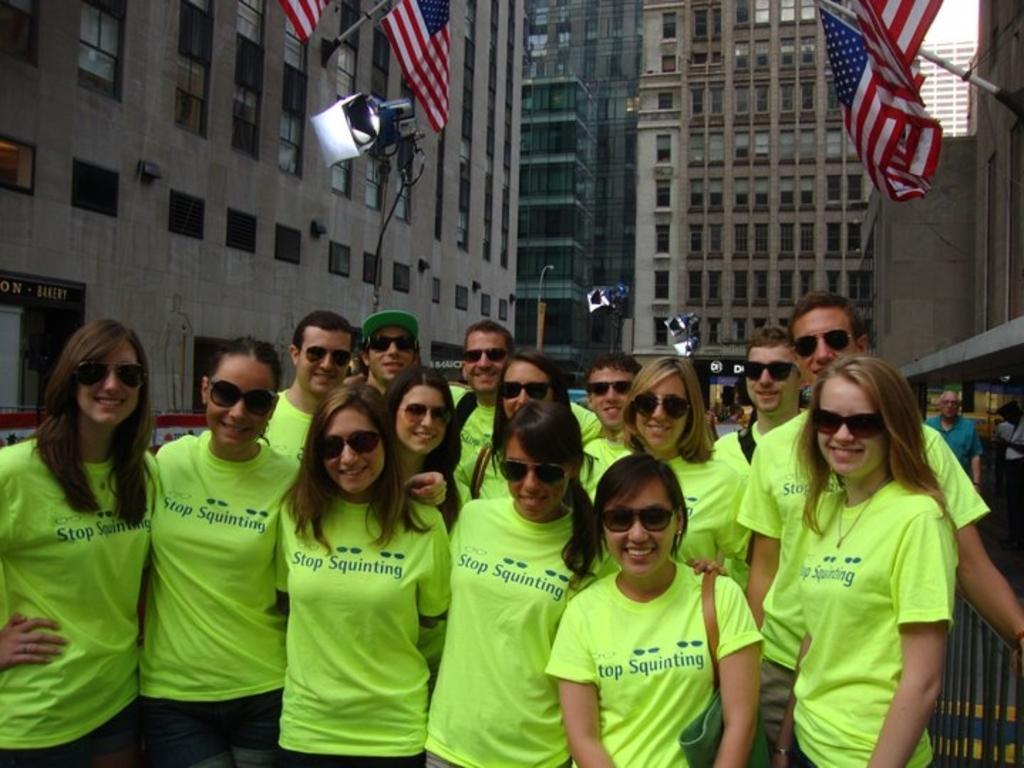Could you give a brief overview of what you see in this image? In this image I can see group of people visible in front of the building , on the building I can see flags and and cameras visible in the middle. 